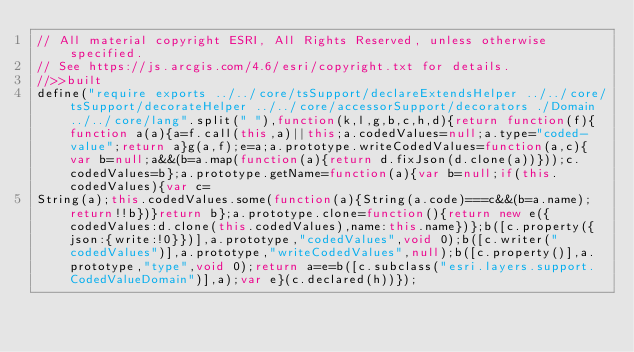<code> <loc_0><loc_0><loc_500><loc_500><_JavaScript_>// All material copyright ESRI, All Rights Reserved, unless otherwise specified.
// See https://js.arcgis.com/4.6/esri/copyright.txt for details.
//>>built
define("require exports ../../core/tsSupport/declareExtendsHelper ../../core/tsSupport/decorateHelper ../../core/accessorSupport/decorators ./Domain ../../core/lang".split(" "),function(k,l,g,b,c,h,d){return function(f){function a(a){a=f.call(this,a)||this;a.codedValues=null;a.type="coded-value";return a}g(a,f);e=a;a.prototype.writeCodedValues=function(a,c){var b=null;a&&(b=a.map(function(a){return d.fixJson(d.clone(a))}));c.codedValues=b};a.prototype.getName=function(a){var b=null;if(this.codedValues){var c=
String(a);this.codedValues.some(function(a){String(a.code)===c&&(b=a.name);return!!b})}return b};a.prototype.clone=function(){return new e({codedValues:d.clone(this.codedValues),name:this.name})};b([c.property({json:{write:!0}})],a.prototype,"codedValues",void 0);b([c.writer("codedValues")],a.prototype,"writeCodedValues",null);b([c.property()],a.prototype,"type",void 0);return a=e=b([c.subclass("esri.layers.support.CodedValueDomain")],a);var e}(c.declared(h))});</code> 